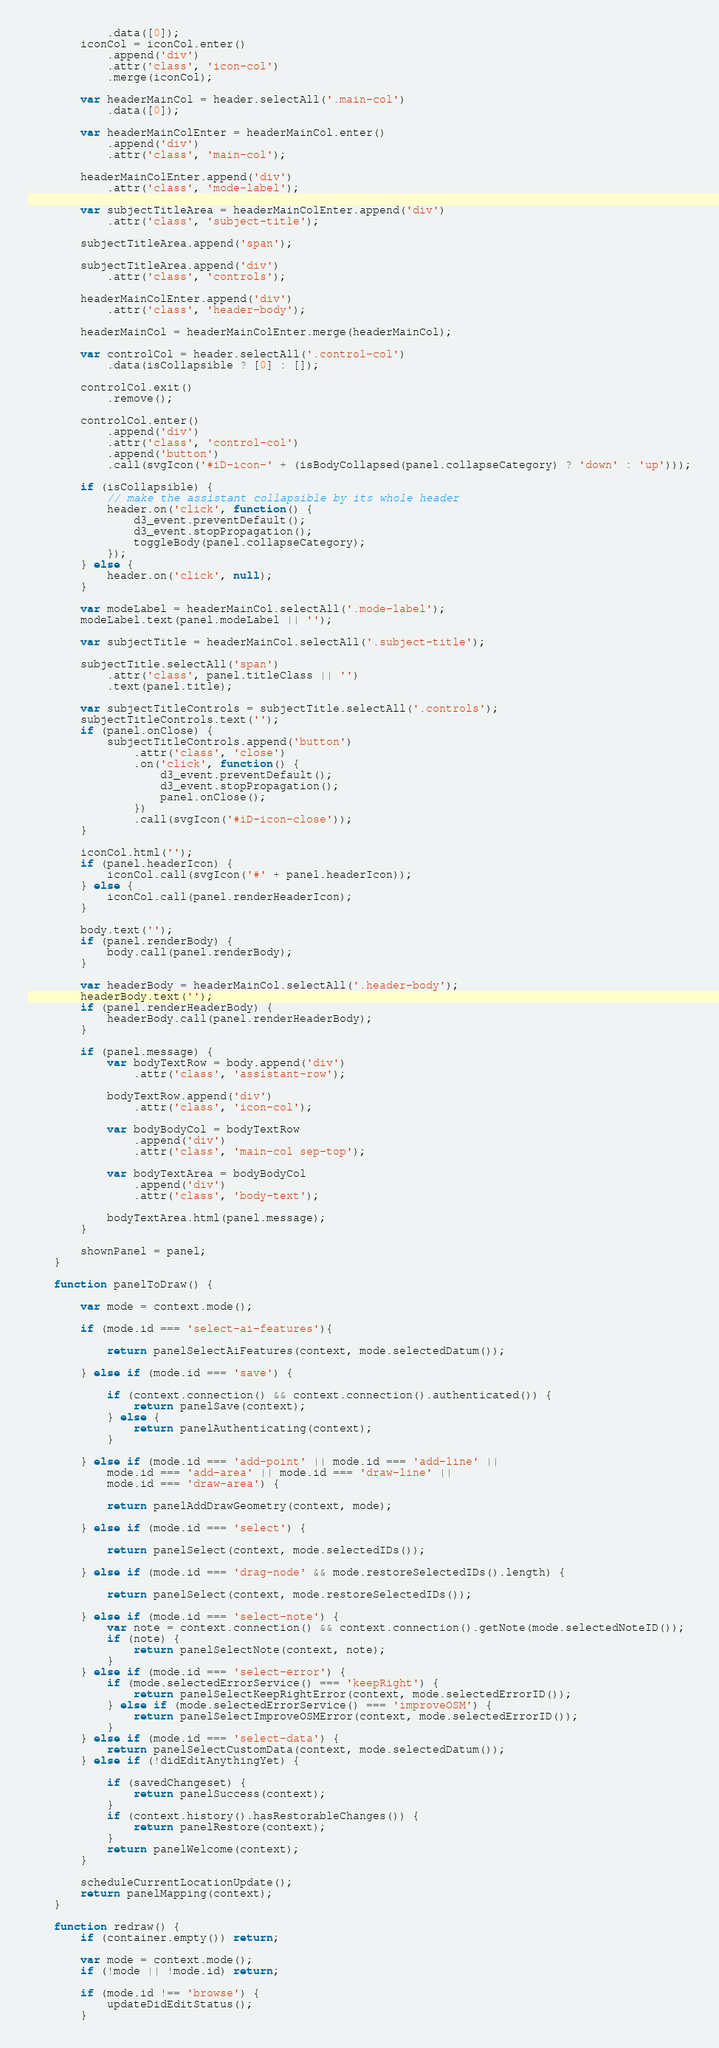<code> <loc_0><loc_0><loc_500><loc_500><_JavaScript_>            .data([0]);
        iconCol = iconCol.enter()
            .append('div')
            .attr('class', 'icon-col')
            .merge(iconCol);

        var headerMainCol = header.selectAll('.main-col')
            .data([0]);

        var headerMainColEnter = headerMainCol.enter()
            .append('div')
            .attr('class', 'main-col');

        headerMainColEnter.append('div')
            .attr('class', 'mode-label');

        var subjectTitleArea = headerMainColEnter.append('div')
            .attr('class', 'subject-title');

        subjectTitleArea.append('span');

        subjectTitleArea.append('div')
            .attr('class', 'controls');

        headerMainColEnter.append('div')
            .attr('class', 'header-body');

        headerMainCol = headerMainColEnter.merge(headerMainCol);

        var controlCol = header.selectAll('.control-col')
            .data(isCollapsible ? [0] : []);

        controlCol.exit()
            .remove();

        controlCol.enter()
            .append('div')
            .attr('class', 'control-col')
            .append('button')
            .call(svgIcon('#iD-icon-' + (isBodyCollapsed(panel.collapseCategory) ? 'down' : 'up')));

        if (isCollapsible) {
            // make the assistant collapsible by its whole header
            header.on('click', function() {
                d3_event.preventDefault();
                d3_event.stopPropagation();
                toggleBody(panel.collapseCategory);
            });
        } else {
            header.on('click', null);
        }

        var modeLabel = headerMainCol.selectAll('.mode-label');
        modeLabel.text(panel.modeLabel || '');

        var subjectTitle = headerMainCol.selectAll('.subject-title');

        subjectTitle.selectAll('span')
            .attr('class', panel.titleClass || '')
            .text(panel.title);

        var subjectTitleControls = subjectTitle.selectAll('.controls');
        subjectTitleControls.text('');
        if (panel.onClose) {
            subjectTitleControls.append('button')
                .attr('class', 'close')
                .on('click', function() {
                    d3_event.preventDefault();
                    d3_event.stopPropagation();
                    panel.onClose();
                })
                .call(svgIcon('#iD-icon-close'));
        }

        iconCol.html('');
        if (panel.headerIcon) {
            iconCol.call(svgIcon('#' + panel.headerIcon));
        } else {
            iconCol.call(panel.renderHeaderIcon);
        }

        body.text('');
        if (panel.renderBody) {
            body.call(panel.renderBody);
        }

        var headerBody = headerMainCol.selectAll('.header-body');
        headerBody.text('');
        if (panel.renderHeaderBody) {
            headerBody.call(panel.renderHeaderBody);
        }

        if (panel.message) {
            var bodyTextRow = body.append('div')
                .attr('class', 'assistant-row');

            bodyTextRow.append('div')
                .attr('class', 'icon-col');

            var bodyBodyCol = bodyTextRow
                .append('div')
                .attr('class', 'main-col sep-top');

            var bodyTextArea = bodyBodyCol
                .append('div')
                .attr('class', 'body-text');

            bodyTextArea.html(panel.message);
        }

        shownPanel = panel;
    }

    function panelToDraw() {

        var mode = context.mode();

        if (mode.id === 'select-ai-features'){
            
            return panelSelectAiFeatures(context, mode.selectedDatum());

        } else if (mode.id === 'save') {

            if (context.connection() && context.connection().authenticated()) {
                return panelSave(context);
            } else {
                return panelAuthenticating(context);
            }

        } else if (mode.id === 'add-point' || mode.id === 'add-line' ||
            mode.id === 'add-area' || mode.id === 'draw-line' ||
            mode.id === 'draw-area') {

            return panelAddDrawGeometry(context, mode);

        } else if (mode.id === 'select') {

            return panelSelect(context, mode.selectedIDs());

        } else if (mode.id === 'drag-node' && mode.restoreSelectedIDs().length) {

            return panelSelect(context, mode.restoreSelectedIDs());

        } else if (mode.id === 'select-note') {
            var note = context.connection() && context.connection().getNote(mode.selectedNoteID());
            if (note) {
                return panelSelectNote(context, note);
            }
        } else if (mode.id === 'select-error') {
            if (mode.selectedErrorService() === 'keepRight') {
                return panelSelectKeepRightError(context, mode.selectedErrorID());
            } else if (mode.selectedErrorService() === 'improveOSM') {
                return panelSelectImproveOSMError(context, mode.selectedErrorID());
            }
        } else if (mode.id === 'select-data') {
            return panelSelectCustomData(context, mode.selectedDatum());
        } else if (!didEditAnythingYet) {

            if (savedChangeset) {
                return panelSuccess(context);
            }
            if (context.history().hasRestorableChanges()) {
                return panelRestore(context);
            }
            return panelWelcome(context);
        }

        scheduleCurrentLocationUpdate();
        return panelMapping(context);
    }

    function redraw() {
        if (container.empty()) return;

        var mode = context.mode();
        if (!mode || !mode.id) return;

        if (mode.id !== 'browse') {
            updateDidEditStatus();
        }
</code> 